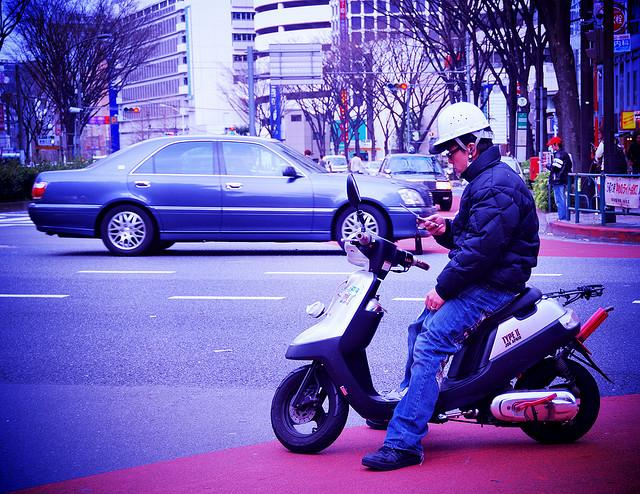In what country is this street found? Please explain your reasoning. japan. The man is in japan. 